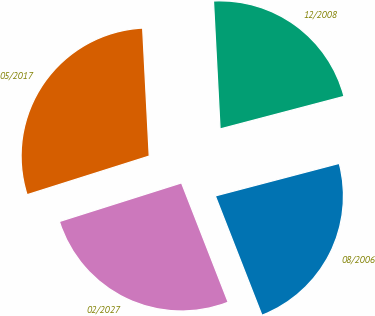<chart> <loc_0><loc_0><loc_500><loc_500><pie_chart><fcel>08/2006<fcel>12/2008<fcel>05/2017<fcel>02/2027<nl><fcel>23.16%<fcel>21.73%<fcel>29.06%<fcel>26.05%<nl></chart> 